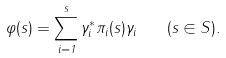Convert formula to latex. <formula><loc_0><loc_0><loc_500><loc_500>\varphi ( s ) = \sum _ { i = 1 } ^ { s } \gamma _ { i } ^ { * } \pi _ { i } ( s ) \gamma _ { i } \quad ( s \in S ) .</formula> 